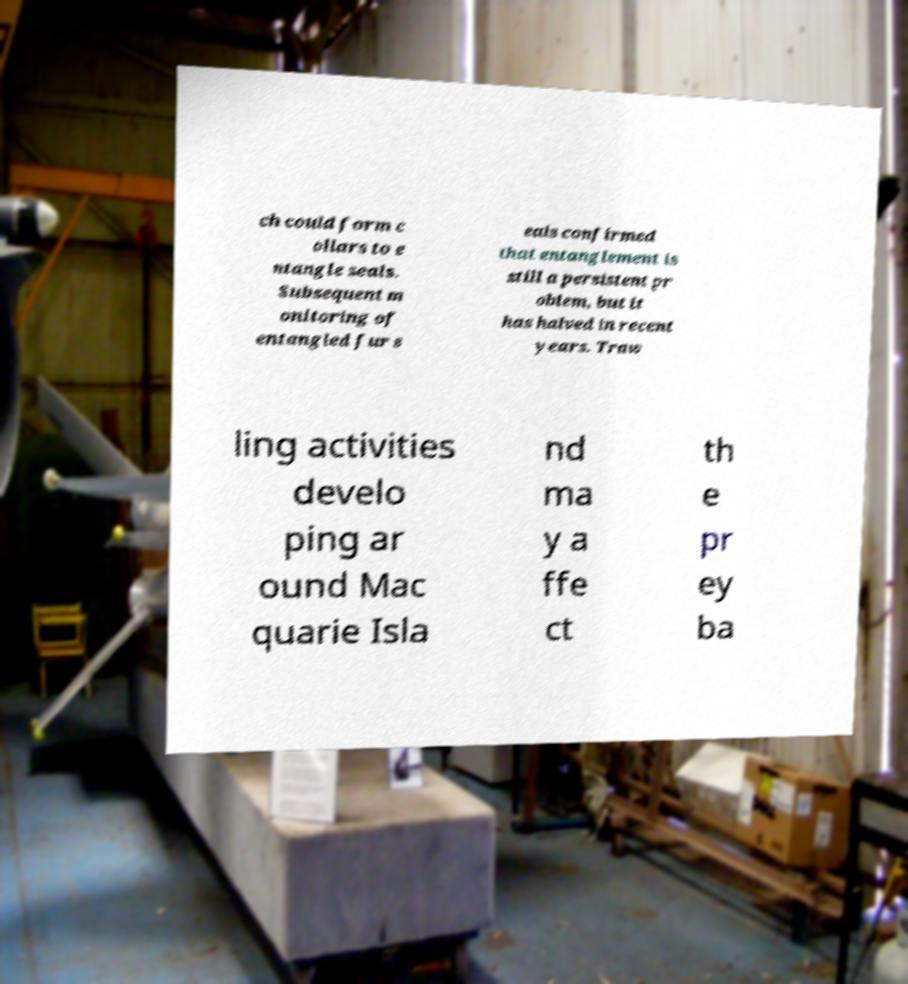Please identify and transcribe the text found in this image. ch could form c ollars to e ntangle seals. Subsequent m onitoring of entangled fur s eals confirmed that entanglement is still a persistent pr oblem, but it has halved in recent years. Traw ling activities develo ping ar ound Mac quarie Isla nd ma y a ffe ct th e pr ey ba 